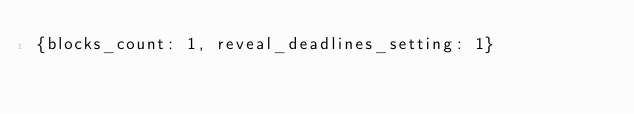Convert code to text. <code><loc_0><loc_0><loc_500><loc_500><_YAML_>{blocks_count: 1, reveal_deadlines_setting: 1}
</code> 